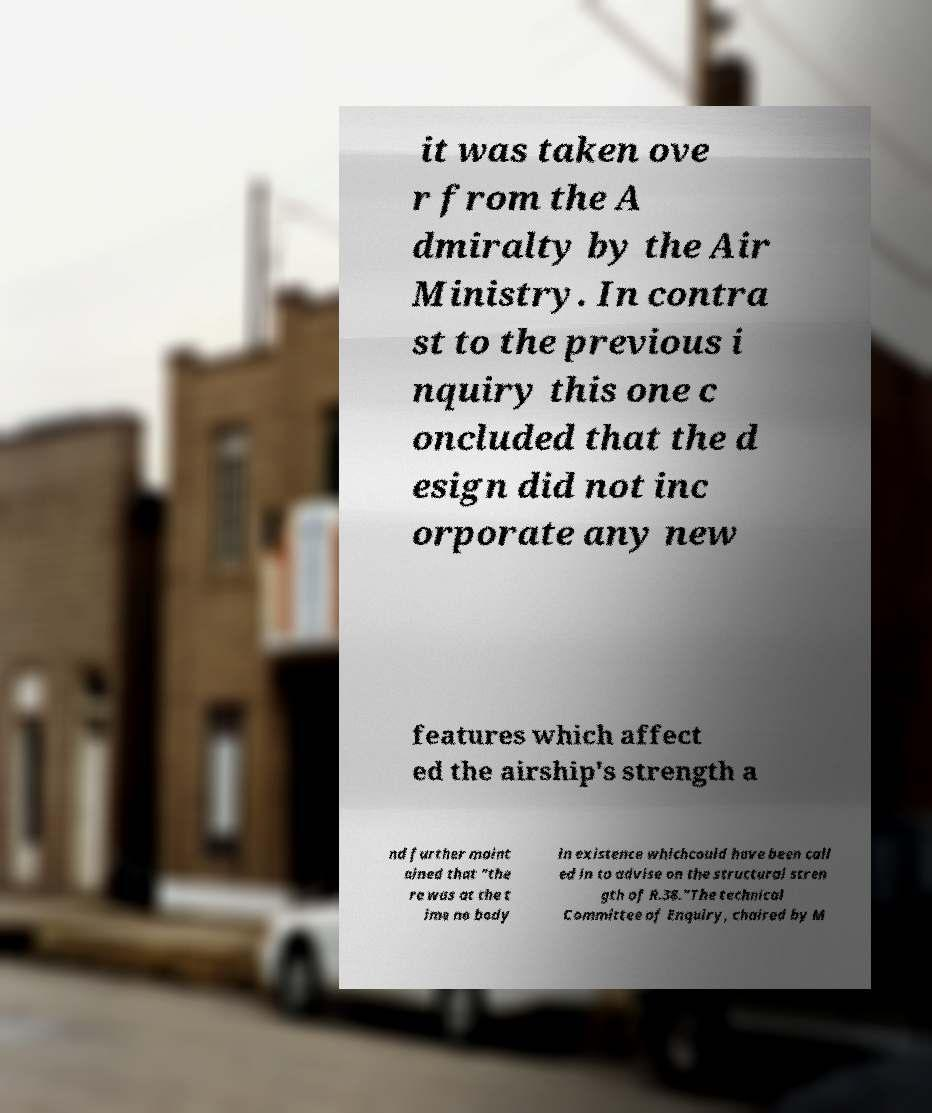There's text embedded in this image that I need extracted. Can you transcribe it verbatim? it was taken ove r from the A dmiralty by the Air Ministry. In contra st to the previous i nquiry this one c oncluded that the d esign did not inc orporate any new features which affect ed the airship's strength a nd further maint ained that "the re was at the t ime no body in existence whichcould have been call ed in to advise on the structural stren gth of R.38."The technical Committee of Enquiry, chaired by M 